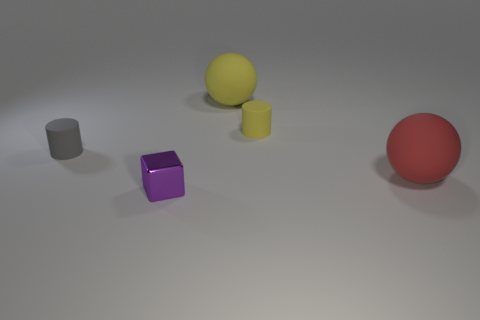Add 1 small matte things. How many objects exist? 6 Subtract 1 cylinders. How many cylinders are left? 1 Subtract all green balls. Subtract all cyan cylinders. How many balls are left? 2 Subtract all metallic blocks. Subtract all red things. How many objects are left? 3 Add 2 big red matte things. How many big red matte things are left? 3 Add 3 tiny metal objects. How many tiny metal objects exist? 4 Subtract all yellow balls. How many balls are left? 1 Subtract 0 purple balls. How many objects are left? 5 Subtract all cubes. How many objects are left? 4 